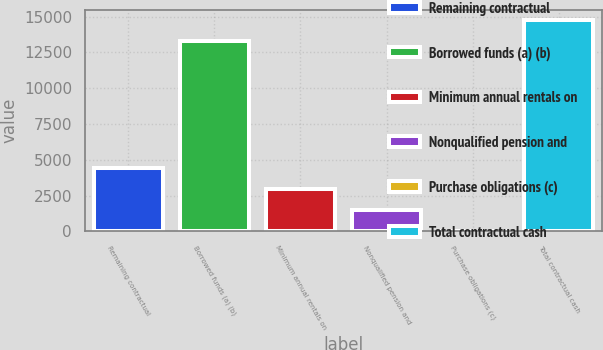Convert chart. <chart><loc_0><loc_0><loc_500><loc_500><bar_chart><fcel>Remaining contractual<fcel>Borrowed funds (a) (b)<fcel>Minimum annual rentals on<fcel>Nonqualified pension and<fcel>Purchase obligations (c)<fcel>Total contractual cash<nl><fcel>4434.3<fcel>13291<fcel>2977.2<fcel>1520.1<fcel>63<fcel>14748.1<nl></chart> 